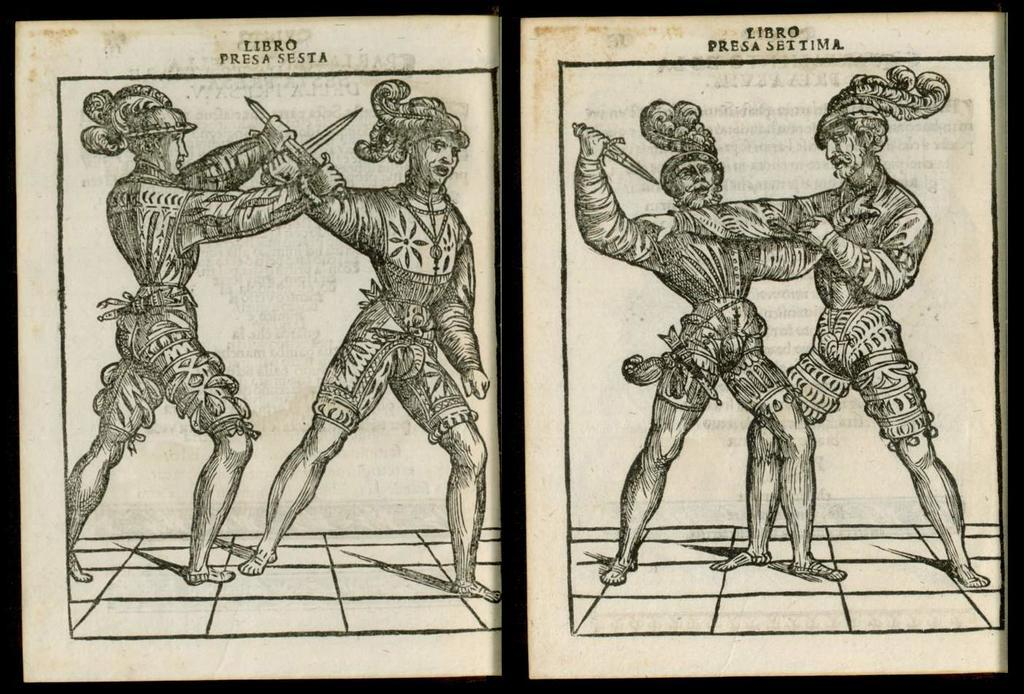What type of artwork is depicted in the image? The image contains a sketch. How many people are present in the sketch? There are four persons in the sketch. What are three of the persons holding? Three of the persons are holding knives. Can you see any ocean waves in the sketch? There is no mention of an ocean or waves in the image, as it contains a sketch of four persons, three of whom are holding knives. 